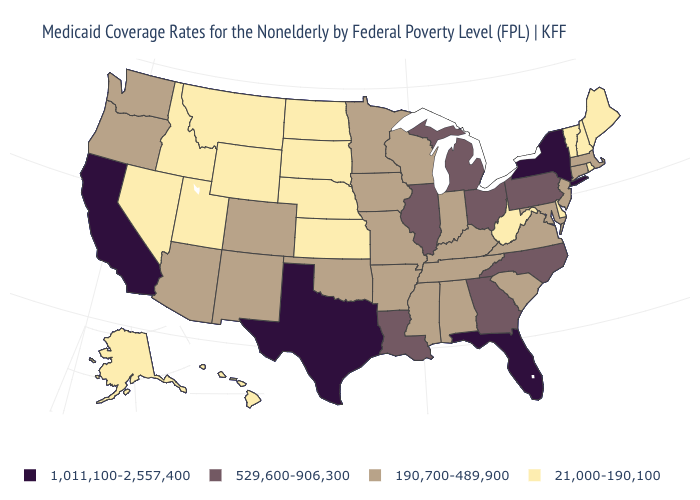Among the states that border New Jersey , which have the highest value?
Be succinct. New York. Name the states that have a value in the range 529,600-906,300?
Give a very brief answer. Georgia, Illinois, Louisiana, Michigan, North Carolina, Ohio, Pennsylvania. Which states have the highest value in the USA?
Concise answer only. California, Florida, New York, Texas. Name the states that have a value in the range 190,700-489,900?
Be succinct. Alabama, Arizona, Arkansas, Colorado, Connecticut, Indiana, Iowa, Kentucky, Maryland, Massachusetts, Minnesota, Mississippi, Missouri, New Jersey, New Mexico, Oklahoma, Oregon, South Carolina, Tennessee, Virginia, Washington, Wisconsin. Which states hav the highest value in the MidWest?
Answer briefly. Illinois, Michigan, Ohio. Among the states that border Ohio , does Pennsylvania have the highest value?
Short answer required. Yes. What is the value of Connecticut?
Write a very short answer. 190,700-489,900. Which states have the lowest value in the West?
Give a very brief answer. Alaska, Hawaii, Idaho, Montana, Nevada, Utah, Wyoming. Which states hav the highest value in the Northeast?
Be succinct. New York. Among the states that border North Carolina , which have the lowest value?
Write a very short answer. South Carolina, Tennessee, Virginia. What is the highest value in the West ?
Short answer required. 1,011,100-2,557,400. Does Massachusetts have the same value as Wisconsin?
Answer briefly. Yes. Does New Hampshire have the lowest value in the Northeast?
Concise answer only. Yes. Does the first symbol in the legend represent the smallest category?
Be succinct. No. What is the value of Ohio?
Write a very short answer. 529,600-906,300. 